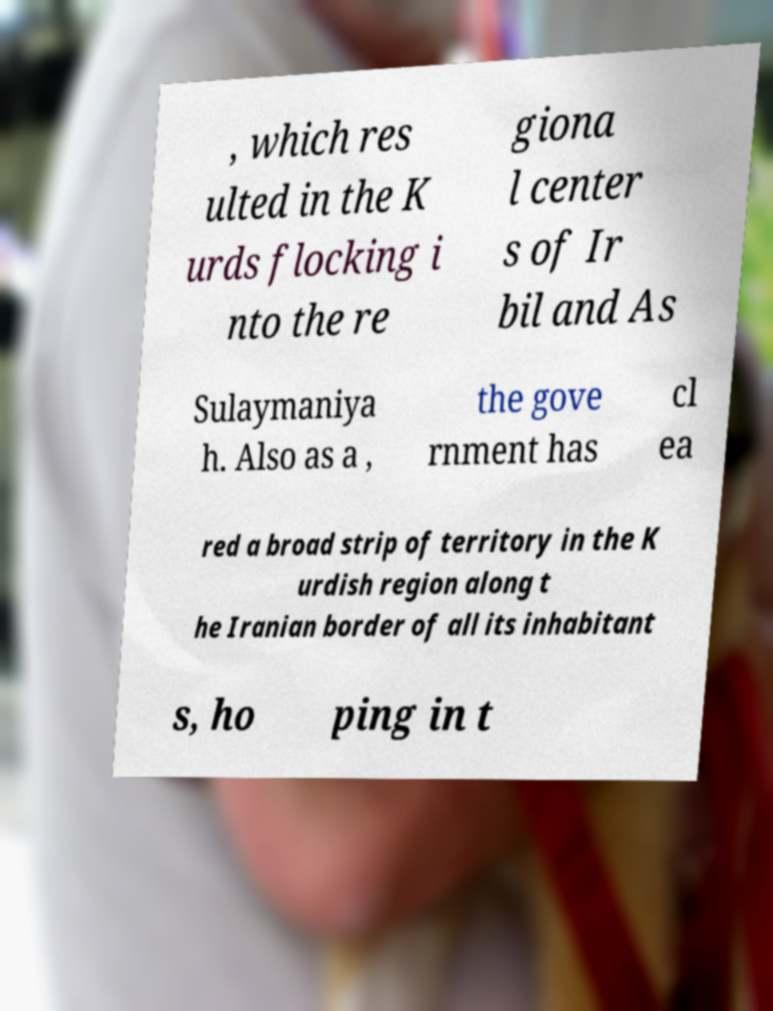Can you accurately transcribe the text from the provided image for me? , which res ulted in the K urds flocking i nto the re giona l center s of Ir bil and As Sulaymaniya h. Also as a , the gove rnment has cl ea red a broad strip of territory in the K urdish region along t he Iranian border of all its inhabitant s, ho ping in t 